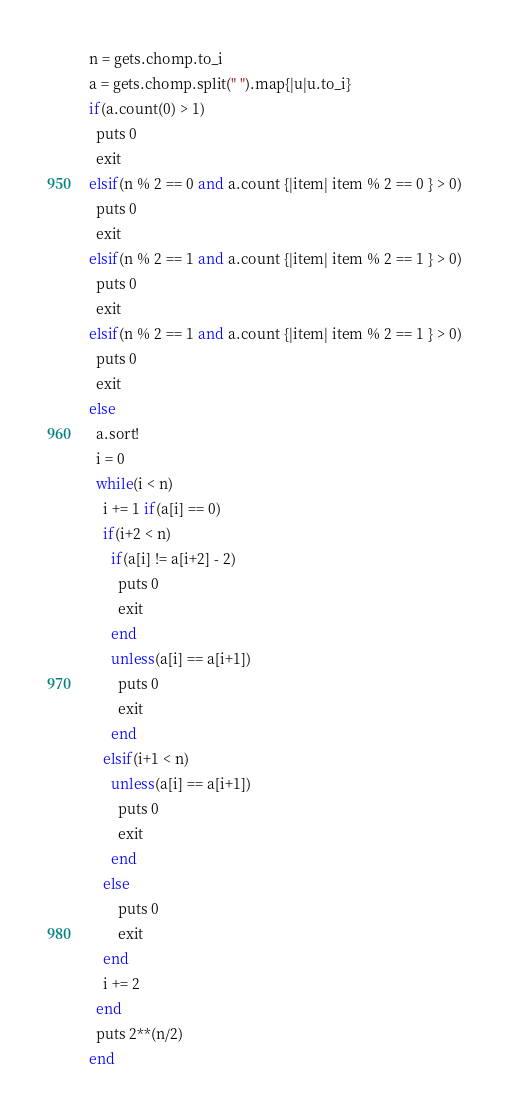Convert code to text. <code><loc_0><loc_0><loc_500><loc_500><_Ruby_>n = gets.chomp.to_i
a = gets.chomp.split(" ").map{|u|u.to_i}
if(a.count(0) > 1) 
  puts 0
  exit
elsif(n % 2 == 0 and a.count {|item| item % 2 == 0 } > 0)
  puts 0
  exit
elsif(n % 2 == 1 and a.count {|item| item % 2 == 1 } > 0)
  puts 0
  exit
elsif(n % 2 == 1 and a.count {|item| item % 2 == 1 } > 0)
  puts 0
  exit
else
  a.sort!
  i = 0
  while(i < n)
    i += 1 if(a[i] == 0)
    if(i+2 < n)
      if(a[i] != a[i+2] - 2)
        puts 0
        exit
      end
      unless(a[i] == a[i+1])
        puts 0
        exit
      end
    elsif(i+1 < n)
      unless(a[i] == a[i+1])
        puts 0
        exit
      end
    else
        puts 0
        exit
    end
    i += 2
  end
  puts 2**(n/2)
end
</code> 